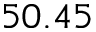Convert formula to latex. <formula><loc_0><loc_0><loc_500><loc_500>5 0 . 4 5</formula> 